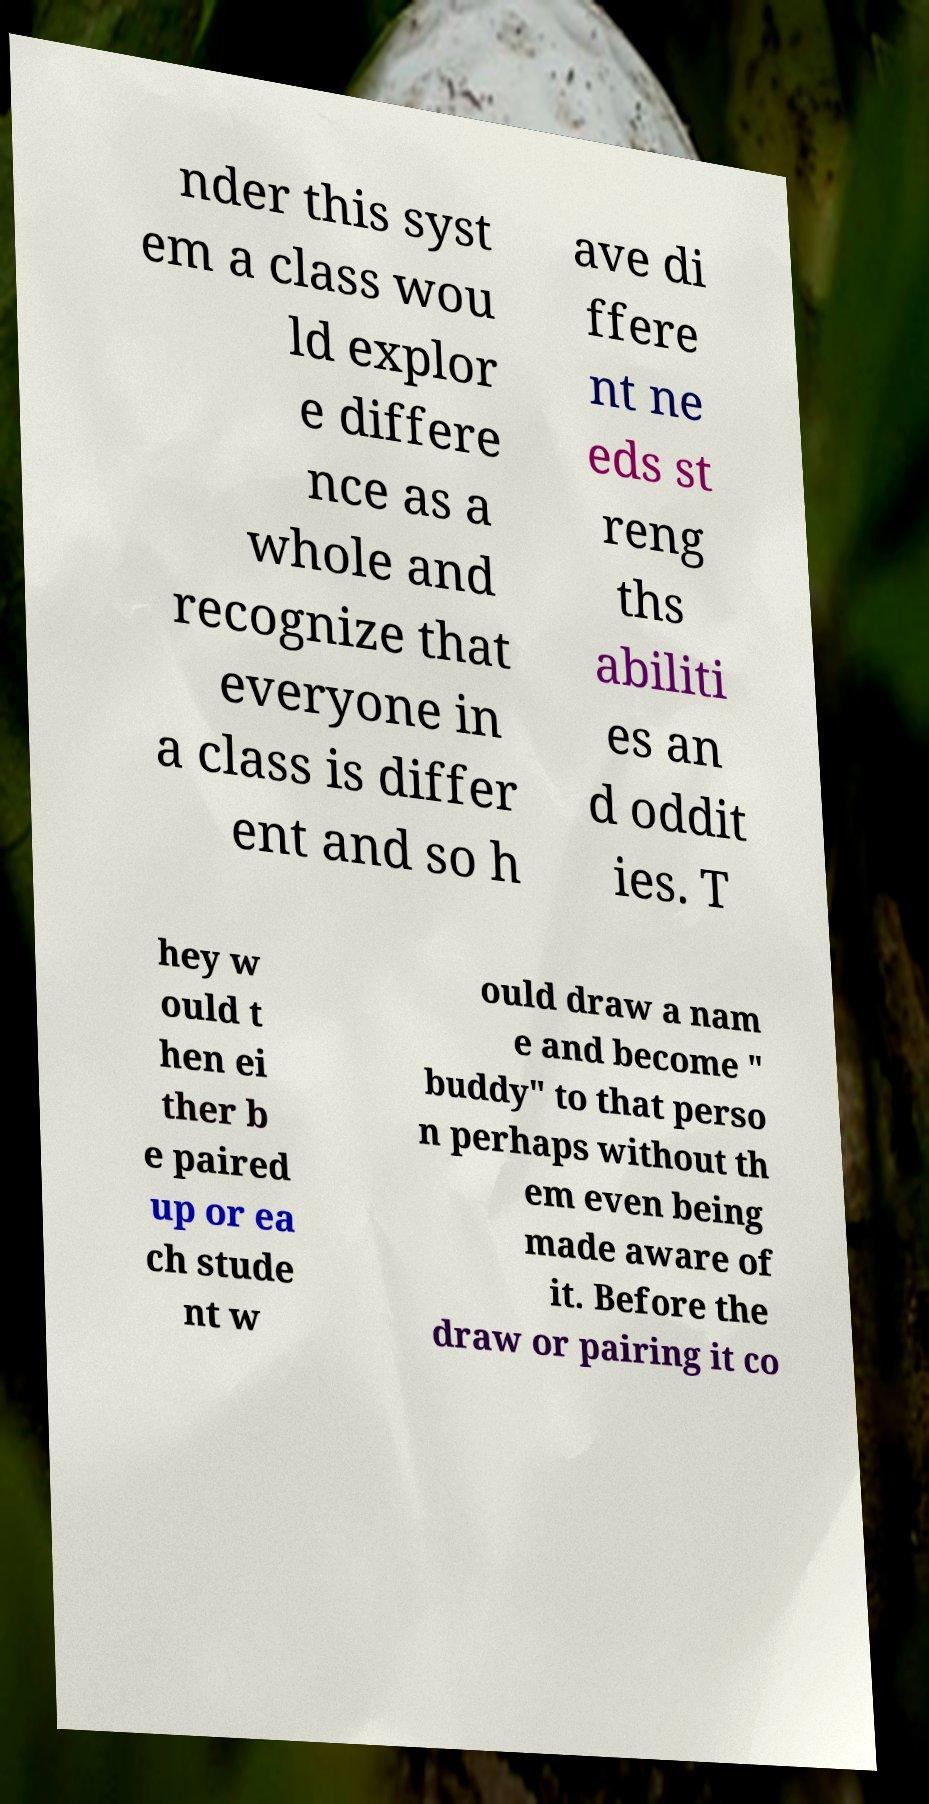I need the written content from this picture converted into text. Can you do that? nder this syst em a class wou ld explor e differe nce as a whole and recognize that everyone in a class is differ ent and so h ave di ffere nt ne eds st reng ths abiliti es an d oddit ies. T hey w ould t hen ei ther b e paired up or ea ch stude nt w ould draw a nam e and become " buddy" to that perso n perhaps without th em even being made aware of it. Before the draw or pairing it co 